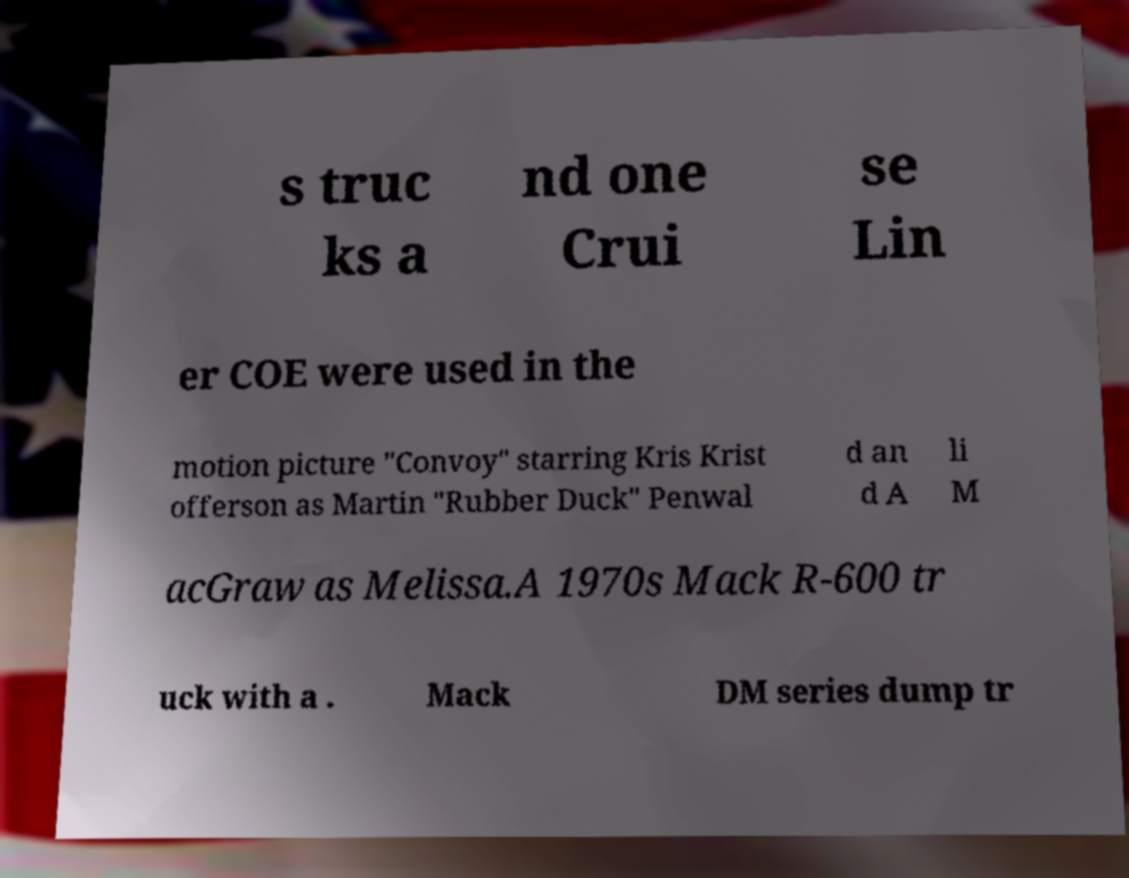Can you read and provide the text displayed in the image?This photo seems to have some interesting text. Can you extract and type it out for me? s truc ks a nd one Crui se Lin er COE were used in the motion picture "Convoy" starring Kris Krist offerson as Martin "Rubber Duck" Penwal d an d A li M acGraw as Melissa.A 1970s Mack R-600 tr uck with a . Mack DM series dump tr 